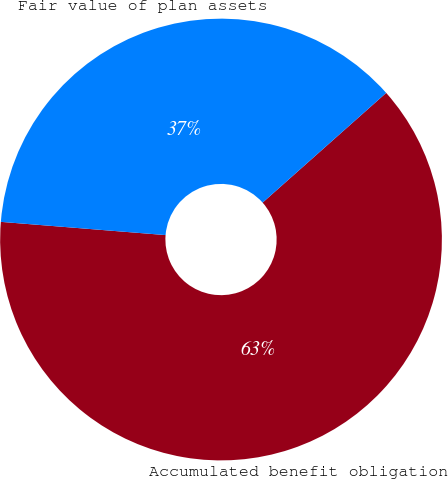<chart> <loc_0><loc_0><loc_500><loc_500><pie_chart><fcel>Accumulated benefit obligation<fcel>Fair value of plan assets<nl><fcel>62.83%<fcel>37.17%<nl></chart> 